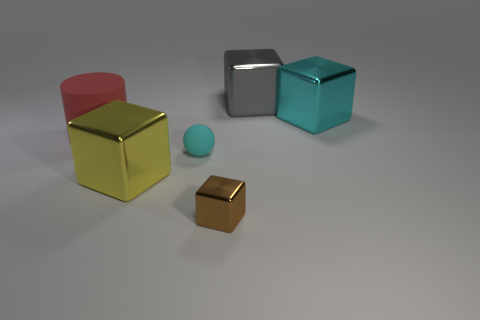Add 3 yellow cubes. How many objects exist? 9 Subtract all gray cubes. How many cubes are left? 3 Subtract all gray cubes. How many cubes are left? 3 Subtract all blocks. How many objects are left? 2 Subtract 2 blocks. How many blocks are left? 2 Subtract all gray cylinders. How many blue spheres are left? 0 Subtract all big metallic cubes. Subtract all large rubber blocks. How many objects are left? 3 Add 4 gray shiny things. How many gray shiny things are left? 5 Add 5 big gray balls. How many big gray balls exist? 5 Subtract 0 red cubes. How many objects are left? 6 